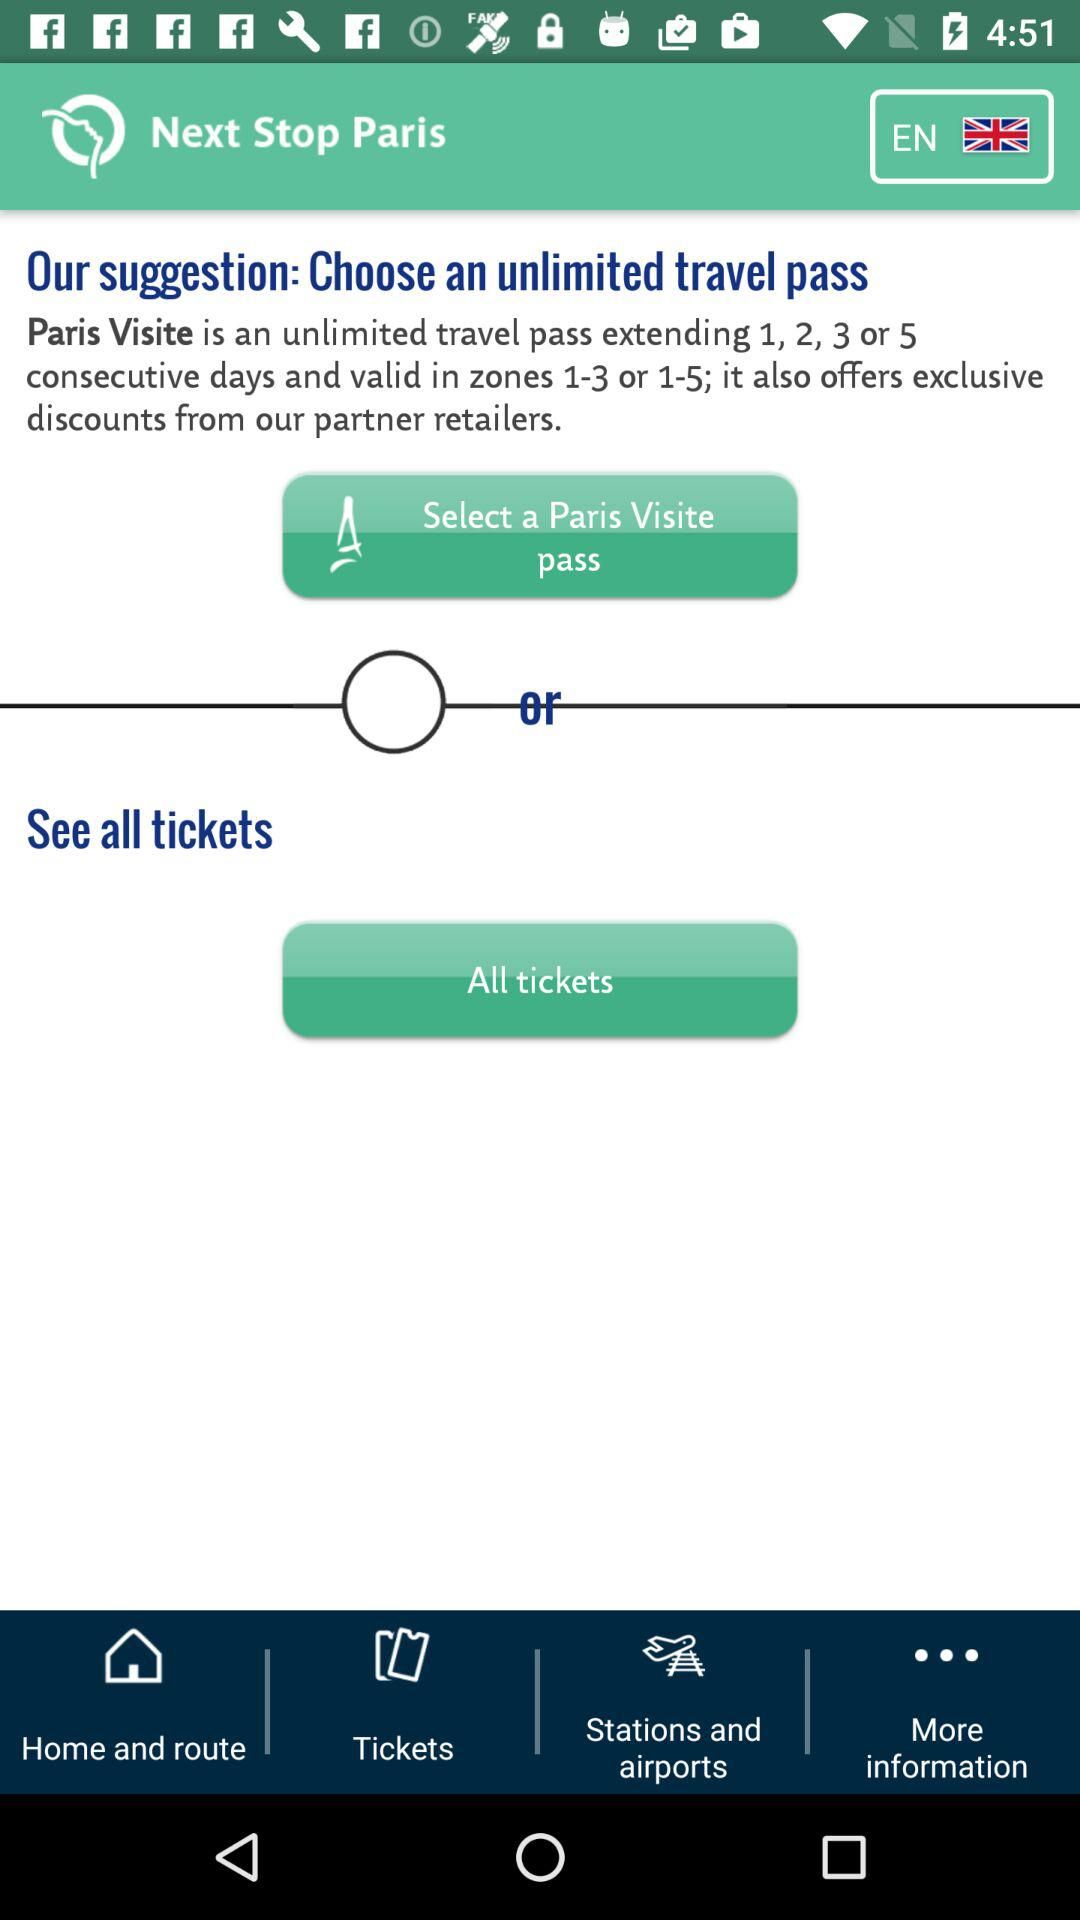Which language is selected? The selected language is English (United Kingdom). 